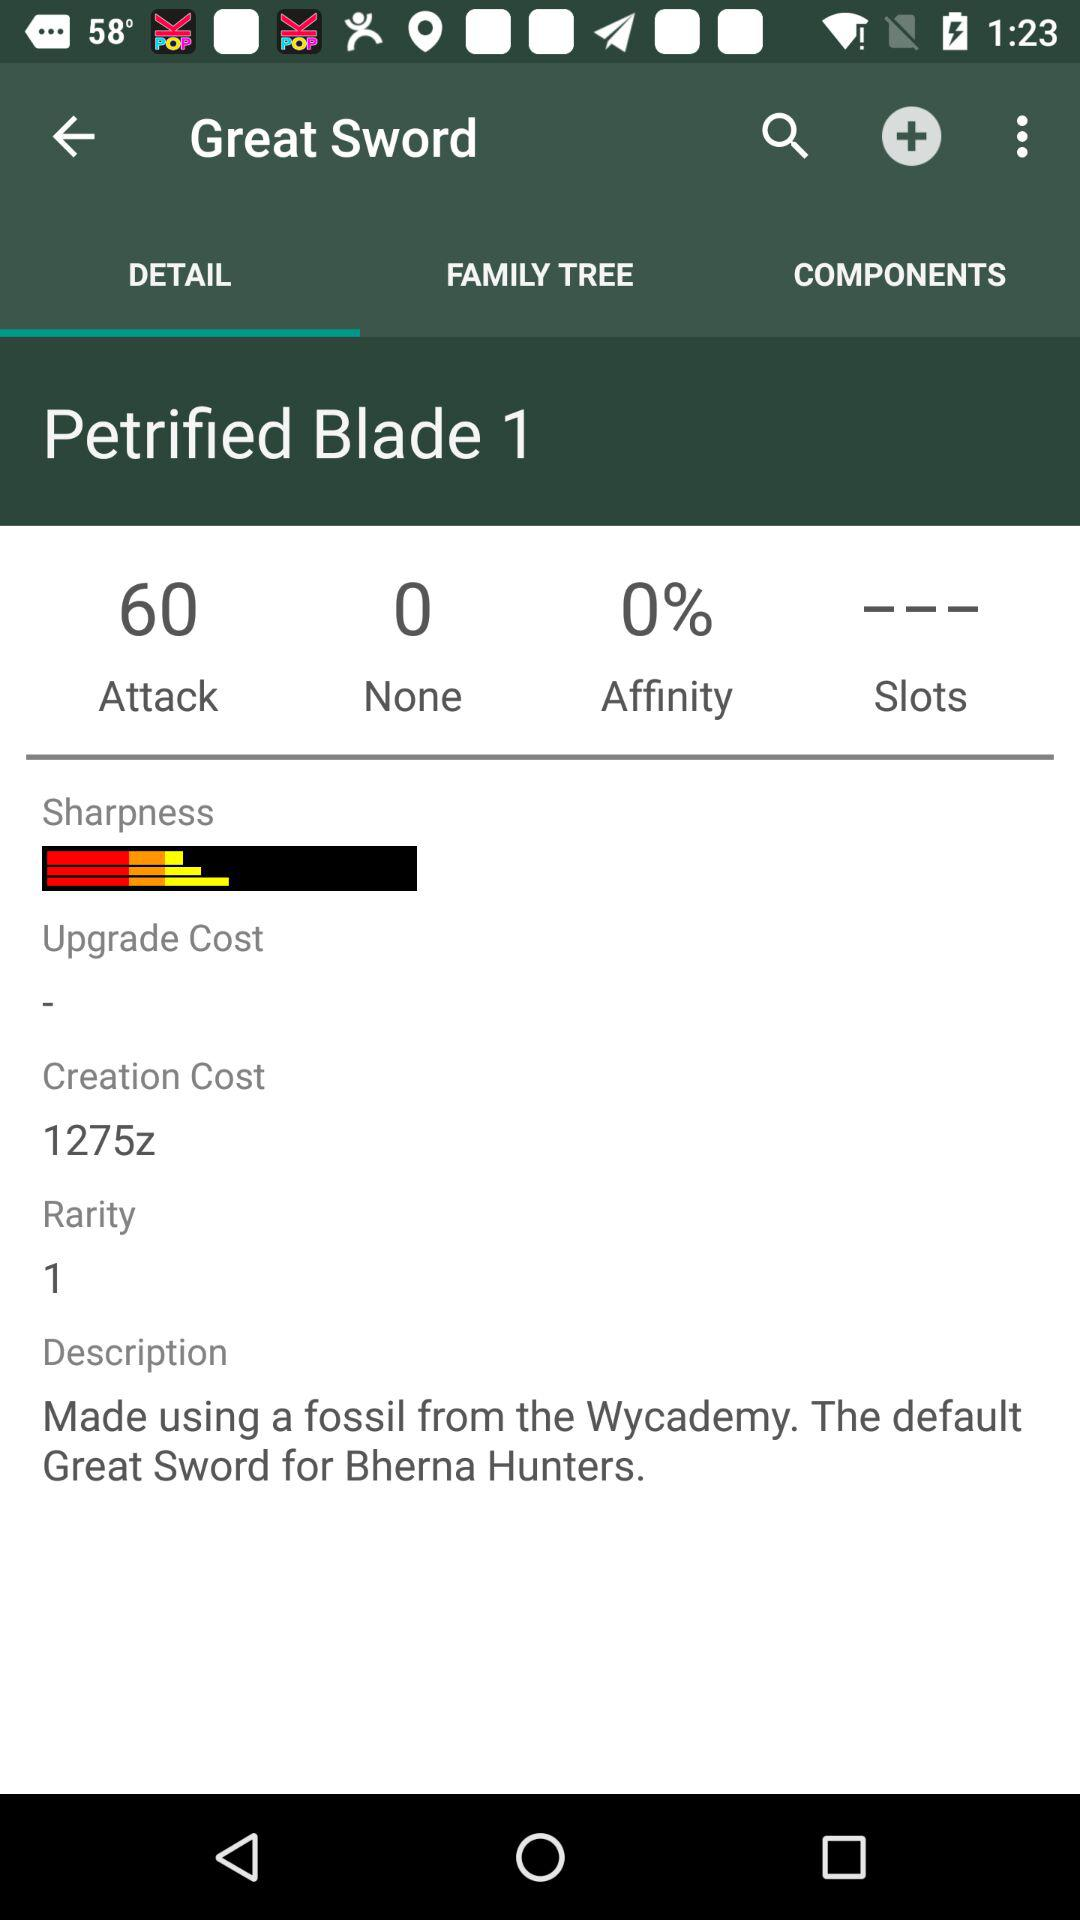What is the number of rarities? The number of rarities is one. 